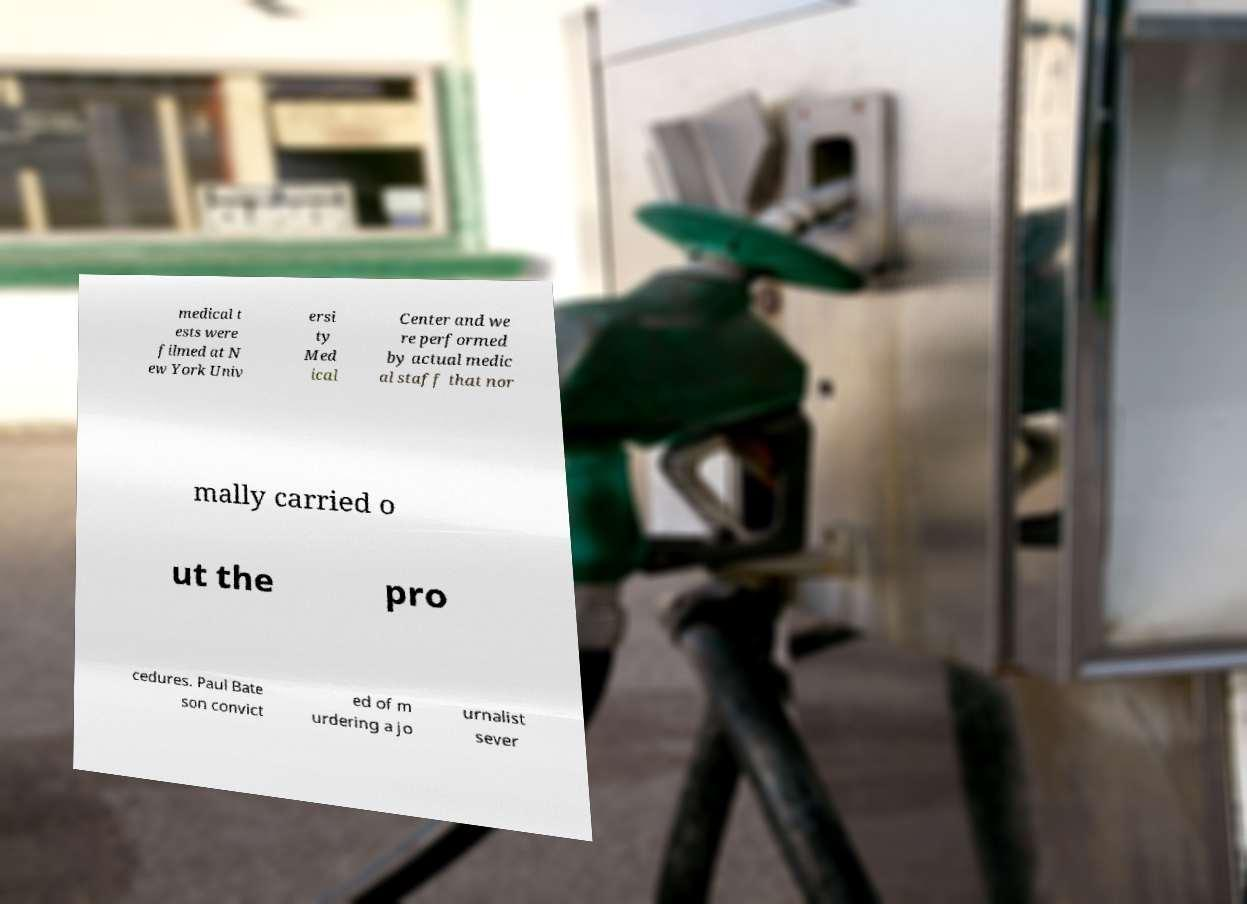Please identify and transcribe the text found in this image. medical t ests were filmed at N ew York Univ ersi ty Med ical Center and we re performed by actual medic al staff that nor mally carried o ut the pro cedures. Paul Bate son convict ed of m urdering a jo urnalist sever 